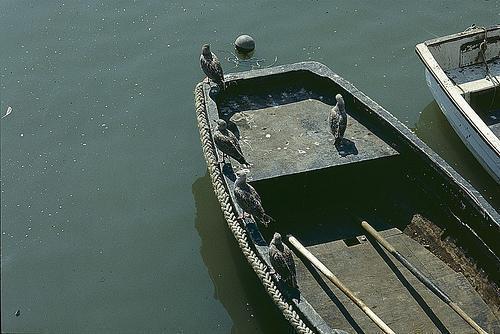What are the two long poles?
Indicate the correct response and explain using: 'Answer: answer
Rationale: rationale.'
Options: Oar handles, paint poles, fishing poles, pool cue. Answer: oar handles.
Rationale: The long poles are in the boat for steering. 